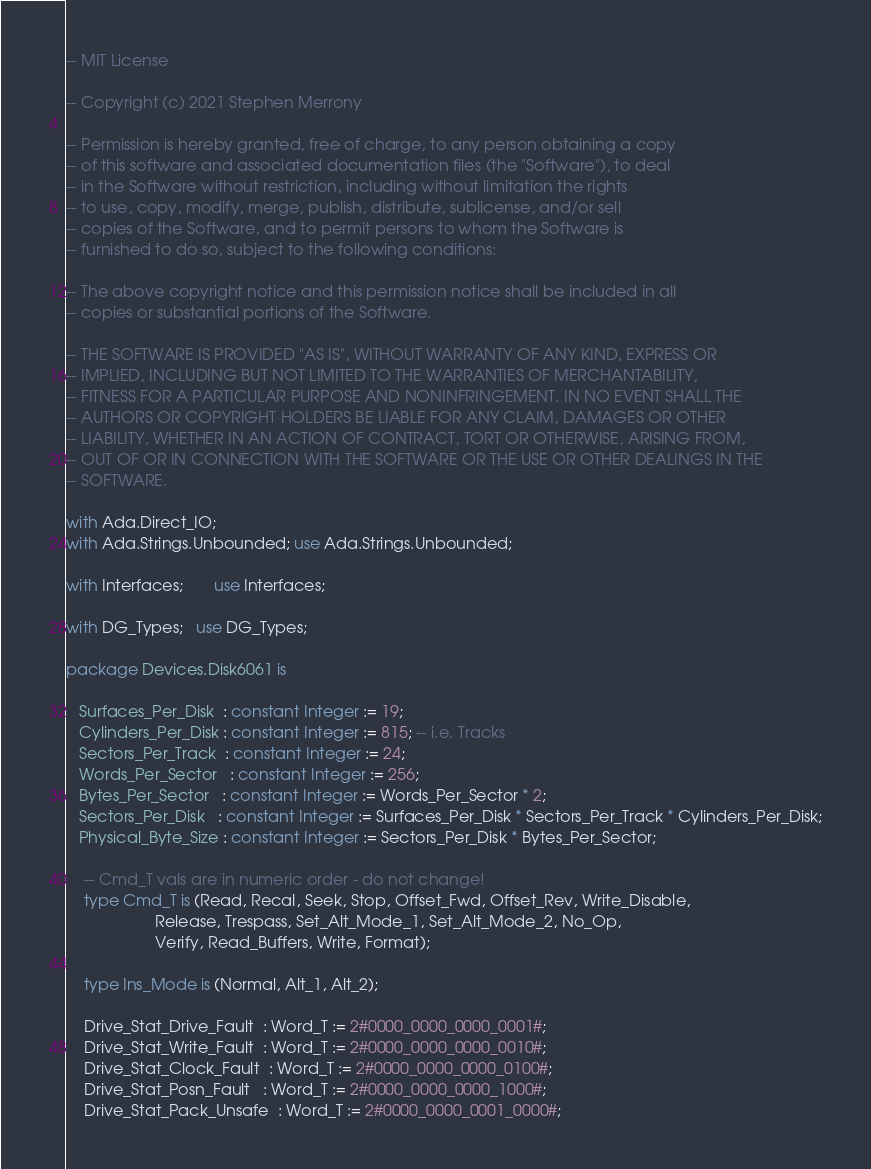<code> <loc_0><loc_0><loc_500><loc_500><_Ada_>-- MIT License

-- Copyright (c) 2021 Stephen Merrony

-- Permission is hereby granted, free of charge, to any person obtaining a copy
-- of this software and associated documentation files (the "Software"), to deal
-- in the Software without restriction, including without limitation the rights
-- to use, copy, modify, merge, publish, distribute, sublicense, and/or sell
-- copies of the Software, and to permit persons to whom the Software is
-- furnished to do so, subject to the following conditions:

-- The above copyright notice and this permission notice shall be included in all
-- copies or substantial portions of the Software.

-- THE SOFTWARE IS PROVIDED "AS IS", WITHOUT WARRANTY OF ANY KIND, EXPRESS OR
-- IMPLIED, INCLUDING BUT NOT LIMITED TO THE WARRANTIES OF MERCHANTABILITY,
-- FITNESS FOR A PARTICULAR PURPOSE AND NONINFRINGEMENT. IN NO EVENT SHALL THE
-- AUTHORS OR COPYRIGHT HOLDERS BE LIABLE FOR ANY CLAIM, DAMAGES OR OTHER
-- LIABILITY, WHETHER IN AN ACTION OF CONTRACT, TORT OR OTHERWISE, ARISING FROM,
-- OUT OF OR IN CONNECTION WITH THE SOFTWARE OR THE USE OR OTHER DEALINGS IN THE
-- SOFTWARE.

with Ada.Direct_IO;
with Ada.Strings.Unbounded; use Ada.Strings.Unbounded;

with Interfaces;       use Interfaces; 

with DG_Types;   use DG_Types;

package Devices.Disk6061 is

   Surfaces_Per_Disk  : constant Integer := 19;
   Cylinders_Per_Disk : constant Integer := 815; -- i.e. Tracks
   Sectors_Per_Track  : constant Integer := 24;
   Words_Per_Sector   : constant Integer := 256;
   Bytes_Per_Sector   : constant Integer := Words_Per_Sector * 2;
   Sectors_Per_Disk   : constant Integer := Surfaces_Per_Disk * Sectors_Per_Track * Cylinders_Per_Disk;
   Physical_Byte_Size : constant Integer := Sectors_Per_Disk * Bytes_Per_Sector;

	-- Cmd_T vals are in numeric order - do not change!
    type Cmd_T is (Read, Recal, Seek, Stop, Offset_Fwd, Offset_Rev, Write_Disable, 
                    Release, Trespass, Set_Alt_Mode_1, Set_Alt_Mode_2, No_Op, 
                    Verify, Read_Buffers, Write, Format);

    type Ins_Mode is (Normal, Alt_1, Alt_2);

	Drive_Stat_Drive_Fault  : Word_T := 2#0000_0000_0000_0001#;
	Drive_Stat_Write_Fault  : Word_T := 2#0000_0000_0000_0010#;
	Drive_Stat_Clock_Fault  : Word_T := 2#0000_0000_0000_0100#;
	Drive_Stat_Posn_Fault   : Word_T := 2#0000_0000_0000_1000#;
	Drive_Stat_Pack_Unsafe  : Word_T := 2#0000_0000_0001_0000#;</code> 